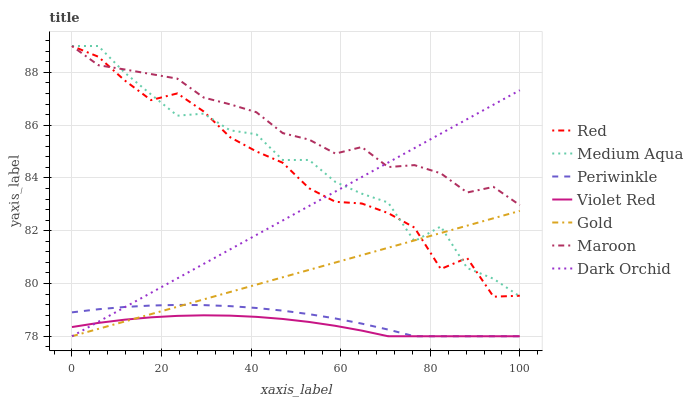Does Gold have the minimum area under the curve?
Answer yes or no. No. Does Gold have the maximum area under the curve?
Answer yes or no. No. Is Gold the smoothest?
Answer yes or no. No. Is Gold the roughest?
Answer yes or no. No. Does Maroon have the lowest value?
Answer yes or no. No. Does Gold have the highest value?
Answer yes or no. No. Is Gold less than Maroon?
Answer yes or no. Yes. Is Medium Aqua greater than Violet Red?
Answer yes or no. Yes. Does Gold intersect Maroon?
Answer yes or no. No. 